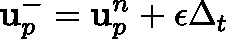<formula> <loc_0><loc_0><loc_500><loc_500>u _ { p } ^ { - } = u _ { p } ^ { n } + \epsilon \Delta _ { t }</formula> 